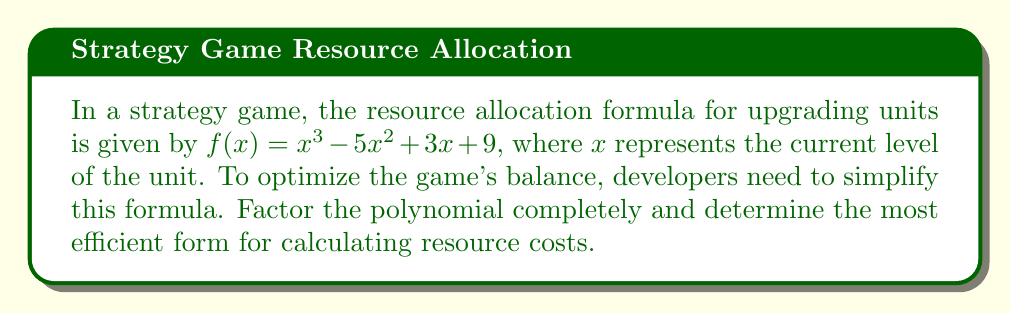Could you help me with this problem? Let's approach this step-by-step:

1) First, we need to check if there are any rational roots. We can use the rational root theorem to list possible roots:
   Factors of 9: ±1, ±3, ±9
   
2) Testing these values, we find that $x = 3$ is a root of the polynomial.

3) We can factor out $(x - 3)$:
   $f(x) = (x - 3)(x^2 + ax + b)$

4) To find $a$ and $b$, we can use polynomial long division or compare coefficients:
   $x^3 - 5x^2 + 3x + 9 = (x - 3)(x^2 + ax + b)$
   $x^3 - 5x^2 + 3x + 9 = x^3 + ax^2 + bx - 3x^2 - 3ax - 3b$

   Comparing coefficients:
   $a - 3 = -5$
   $b - 3a = 3$
   $-3b = 9$

   Solving this system, we get $a = -2$ and $b = -3$

5) Therefore, our factored polynomial is:
   $f(x) = (x - 3)(x^2 - 2x - 3)$

6) We can factor the quadratic term further:
   $x^2 - 2x - 3 = (x - 3)(x + 1)$

7) Thus, the completely factored form is:
   $f(x) = (x - 3)^2(x + 1)$

This factored form is the most efficient for calculation, as it reduces the number of multiplications needed.
Answer: $f(x) = (x - 3)^2(x + 1)$ 